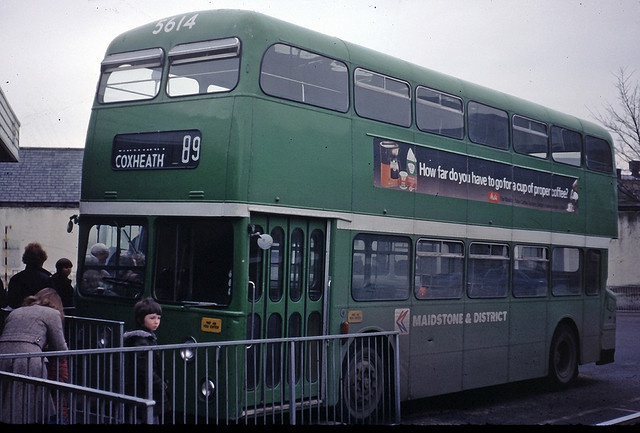Describe the objects in this image and their specific colors. I can see bus in lavender, black, gray, and purple tones, people in lavender, purple, and black tones, people in lavender, black, and gray tones, people in lavender, black, and gray tones, and people in lavender, black, gray, and darkgray tones in this image. 